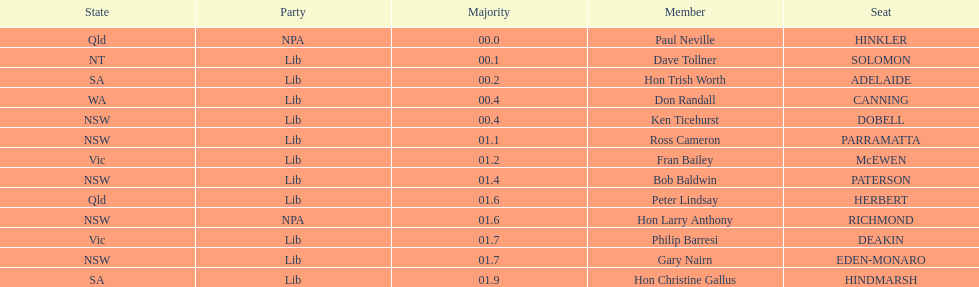What member comes next after hon trish worth? Don Randall. 